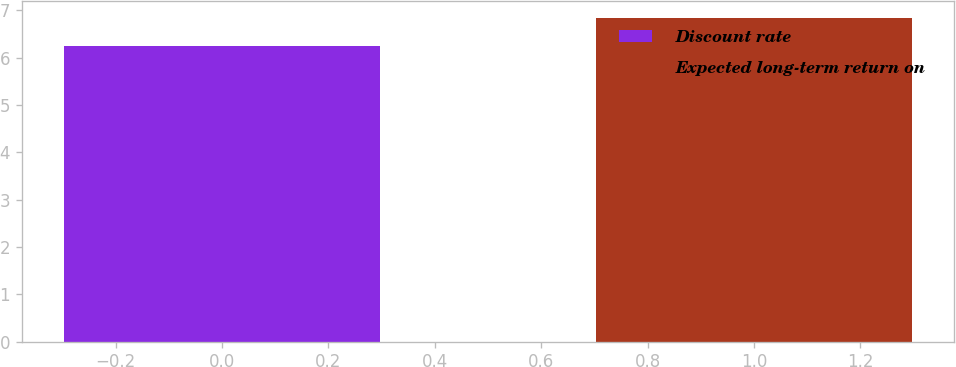<chart> <loc_0><loc_0><loc_500><loc_500><bar_chart><fcel>Discount rate<fcel>Expected long-term return on<nl><fcel>6.25<fcel>6.85<nl></chart> 